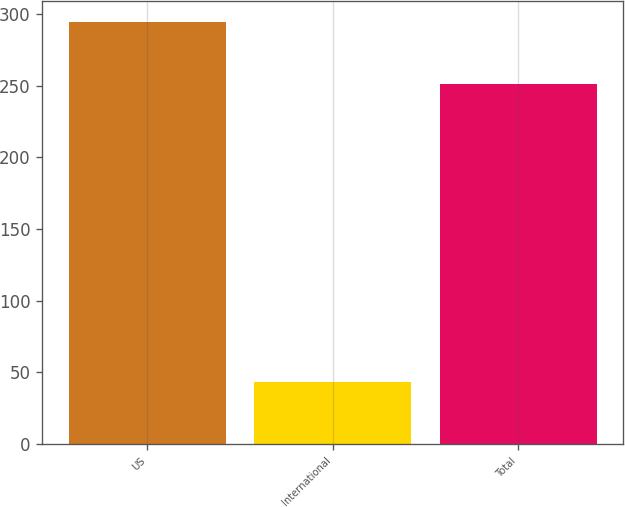<chart> <loc_0><loc_0><loc_500><loc_500><bar_chart><fcel>US<fcel>International<fcel>Total<nl><fcel>294<fcel>43<fcel>251<nl></chart> 